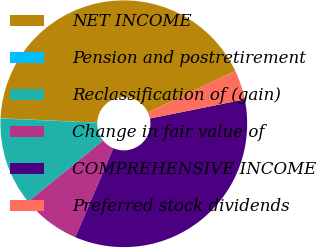Convert chart. <chart><loc_0><loc_0><loc_500><loc_500><pie_chart><fcel>NET INCOME<fcel>Pension and postretirement<fcel>Reclassification of (gain)<fcel>Change in fair value of<fcel>COMPREHENSIVE INCOME<fcel>Preferred stock dividends<nl><fcel>42.25%<fcel>0.04%<fcel>11.54%<fcel>7.71%<fcel>34.59%<fcel>3.87%<nl></chart> 